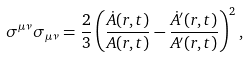Convert formula to latex. <formula><loc_0><loc_0><loc_500><loc_500>\sigma ^ { \mu \nu } \sigma _ { \mu \nu } = \frac { 2 } { 3 } \left ( \frac { \dot { A } ( r , t ) } { A ( r , t ) } - \frac { \dot { A } ^ { \prime } ( r , t ) } { A ^ { \prime } ( r , t ) } \right ) ^ { 2 } ,</formula> 